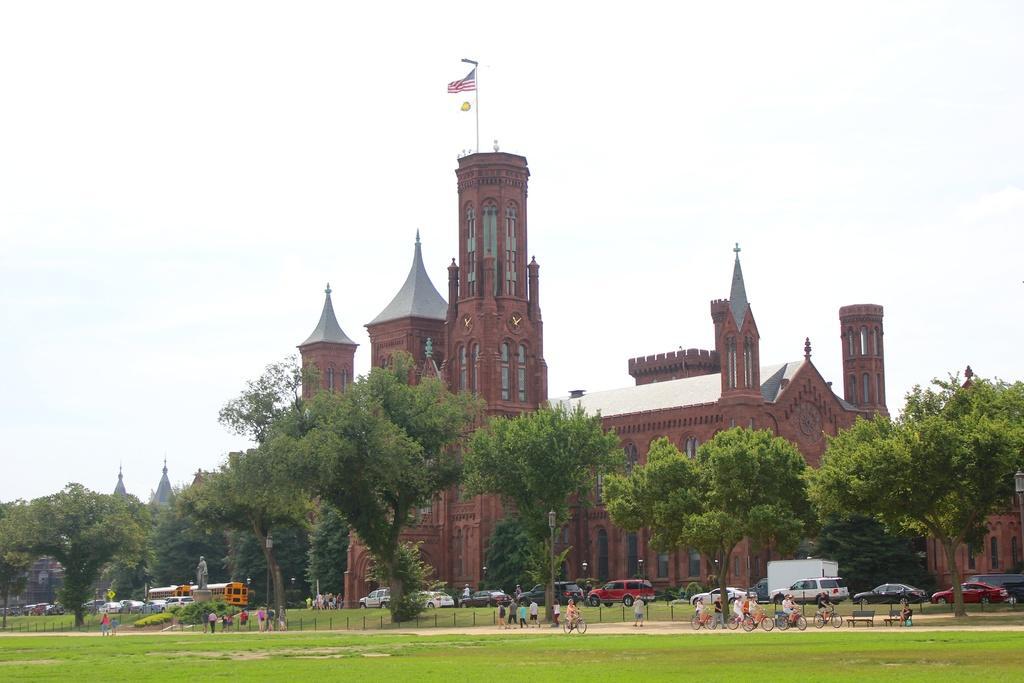Could you give a brief overview of what you see in this image? This image consists of a building in red color. At the top, there is a flag. At the bottom, we can see many persons walking and cycling on the ground and there is green grass. In the front, there are many trees. At the top, there is sky. 